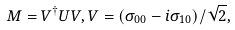Convert formula to latex. <formula><loc_0><loc_0><loc_500><loc_500>M = V ^ { \dagger } U V , V = ( \sigma _ { 0 0 } - i \sigma _ { 1 0 } ) / \sqrt { 2 } ,</formula> 